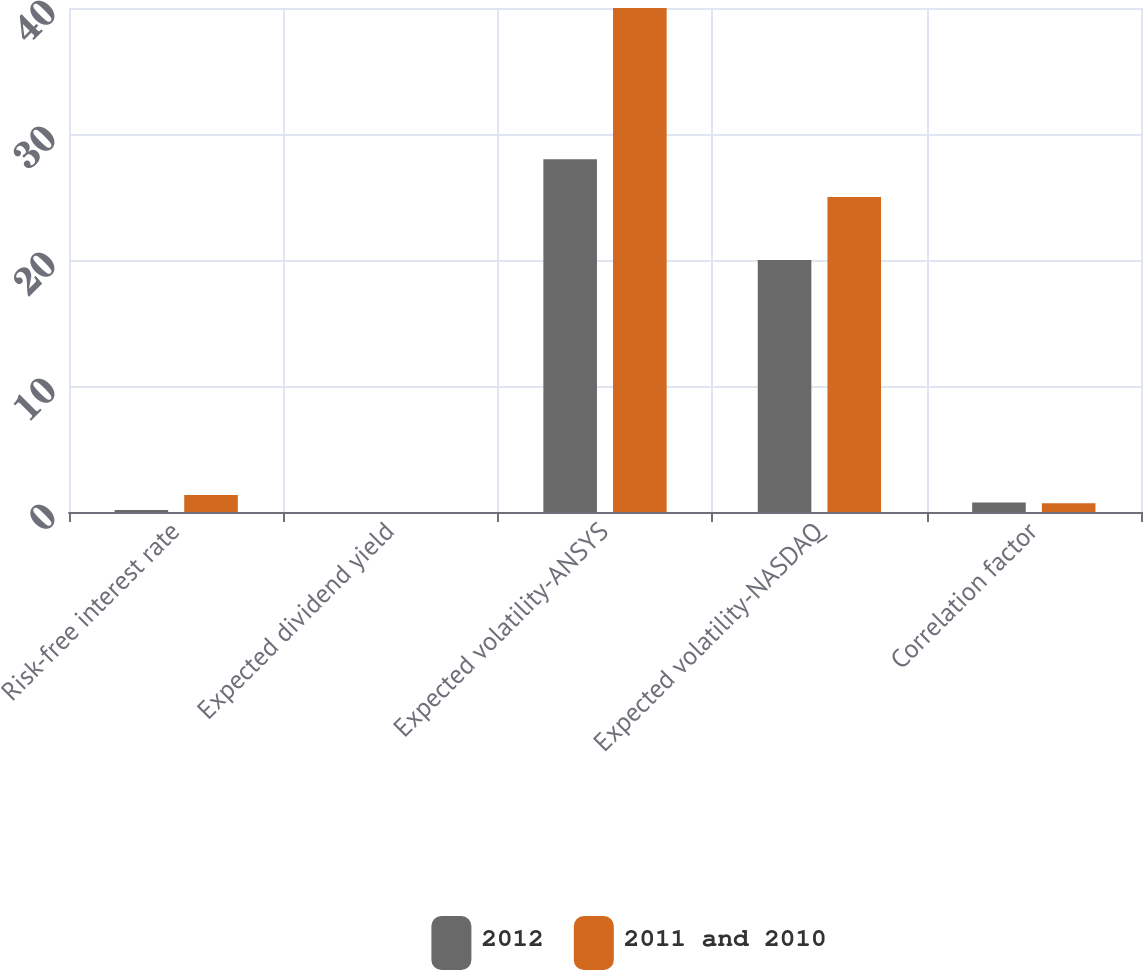Convert chart. <chart><loc_0><loc_0><loc_500><loc_500><stacked_bar_chart><ecel><fcel>Risk-free interest rate<fcel>Expected dividend yield<fcel>Expected volatility-ANSYS<fcel>Expected volatility-NASDAQ<fcel>Correlation factor<nl><fcel>2012<fcel>0.16<fcel>0<fcel>28<fcel>20<fcel>0.75<nl><fcel>2011 and 2010<fcel>1.35<fcel>0<fcel>40<fcel>25<fcel>0.7<nl></chart> 